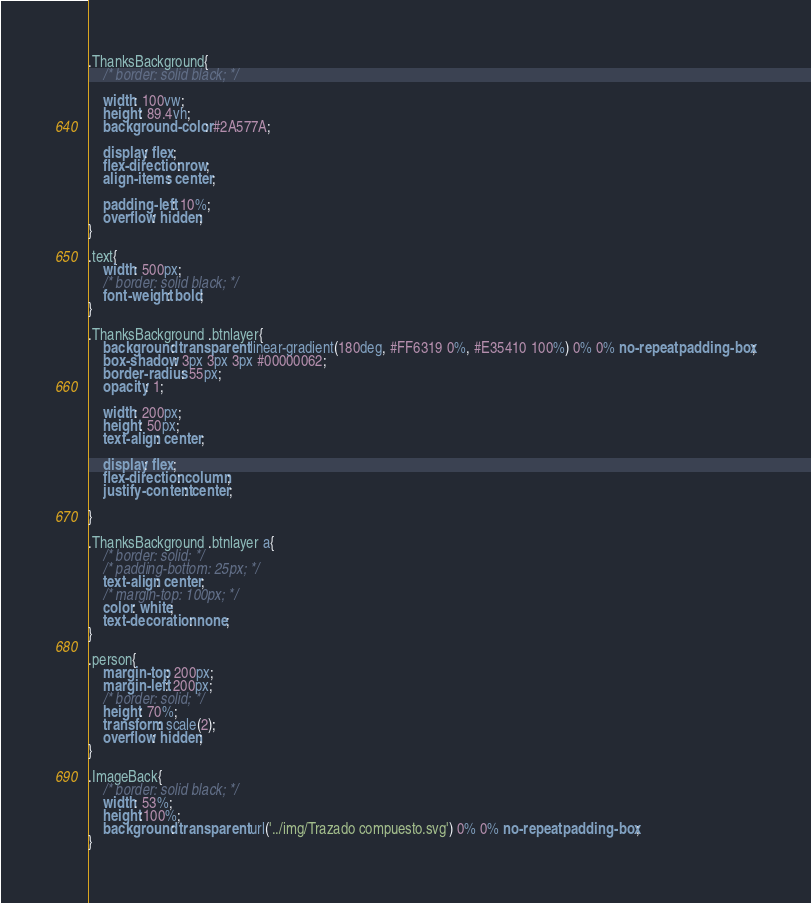<code> <loc_0><loc_0><loc_500><loc_500><_CSS_>.ThanksBackground{
	/* border: solid black; */

	width: 100vw;
	height: 89.4vh;
	background-color: #2A577A;

	display: flex;
	flex-direction: row;
	align-items: center;

	padding-left: 10%;
	overflow: hidden;
}

.text{
	width: 500px;
	/* border: solid black; */
	font-weight: bold;
}

.ThanksBackground .btnlayer{
	background: transparent linear-gradient(180deg, #FF6319 0%, #E35410 100%) 0% 0% no-repeat padding-box;
	box-shadow: 3px 3px 3px #00000062;
	border-radius: 55px;
	opacity: 1;

	width: 200px;
	height: 50px;
	text-align: center;

	display: flex;
	flex-direction: column;
	justify-content: center;

}

.ThanksBackground .btnlayer a{
	/* border: solid; */
	/* padding-bottom: 25px; */
	text-align: center;
	/* margin-top: 100px; */
	color: white;
	text-decoration: none;
}

.person{
	margin-top: 200px;
	margin-left: 200px;
	/* border: solid; */
	height: 70%;
	transform: scale(2);
	overflow: hidden;
}

.ImageBack{
	/* border: solid black; */
	width: 53%;
	height:100%;
	background: transparent url('../img/Trazado compuesto.svg') 0% 0% no-repeat padding-box;
}</code> 